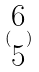<formula> <loc_0><loc_0><loc_500><loc_500>( \begin{matrix} 6 \\ 5 \end{matrix} )</formula> 